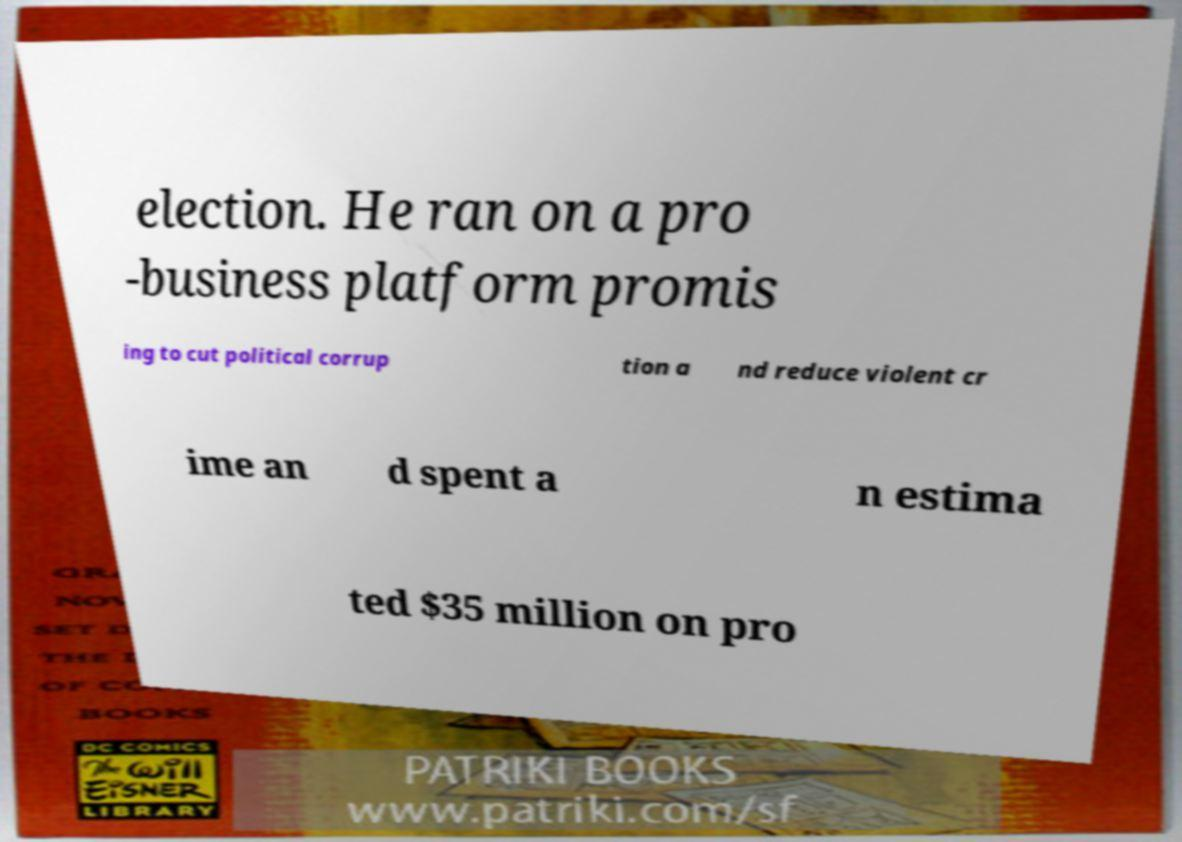Can you accurately transcribe the text from the provided image for me? election. He ran on a pro -business platform promis ing to cut political corrup tion a nd reduce violent cr ime an d spent a n estima ted $35 million on pro 